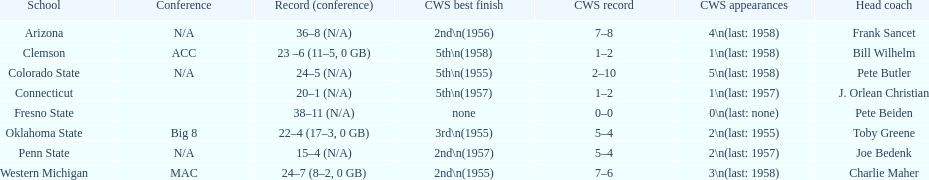List the schools that came in last place in the cws best finish. Clemson, Colorado State, Connecticut. 